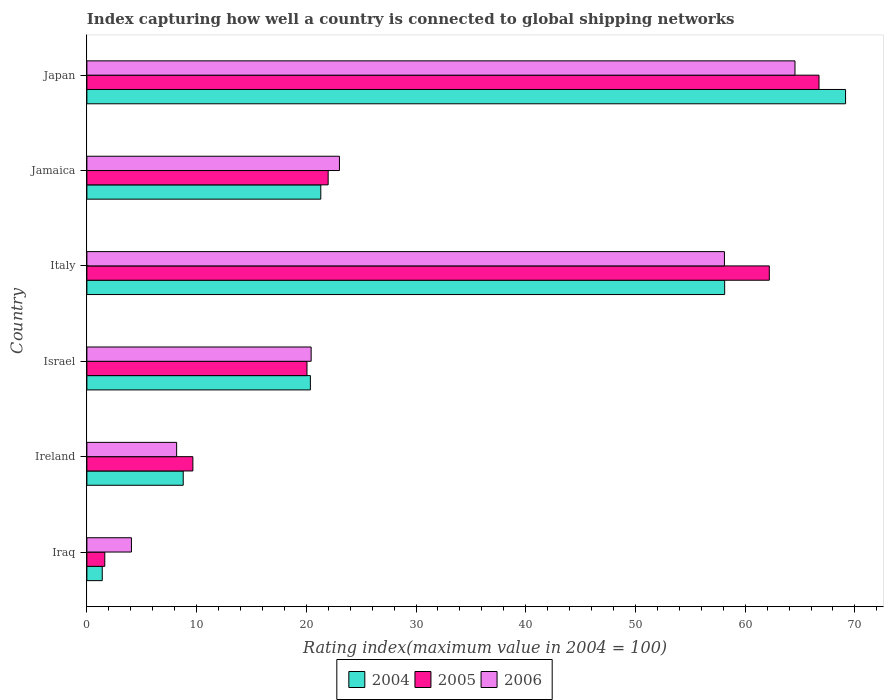Are the number of bars per tick equal to the number of legend labels?
Offer a very short reply. Yes. How many bars are there on the 3rd tick from the top?
Keep it short and to the point. 3. How many bars are there on the 3rd tick from the bottom?
Your answer should be compact. 3. In how many cases, is the number of bars for a given country not equal to the number of legend labels?
Offer a very short reply. 0. What is the rating index in 2005 in Iraq?
Ensure brevity in your answer.  1.63. Across all countries, what is the maximum rating index in 2006?
Provide a short and direct response. 64.54. Across all countries, what is the minimum rating index in 2006?
Ensure brevity in your answer.  4.06. In which country was the rating index in 2006 maximum?
Your answer should be very brief. Japan. In which country was the rating index in 2004 minimum?
Offer a terse response. Iraq. What is the total rating index in 2005 in the graph?
Provide a succinct answer. 182.27. What is the difference between the rating index in 2005 in Ireland and that in Japan?
Provide a succinct answer. -57.07. What is the difference between the rating index in 2006 in Israel and the rating index in 2004 in Japan?
Your answer should be compact. -48.71. What is the average rating index in 2006 per country?
Offer a very short reply. 29.72. What is the difference between the rating index in 2004 and rating index in 2006 in Israel?
Ensure brevity in your answer.  -0.07. What is the ratio of the rating index in 2006 in Iraq to that in Israel?
Ensure brevity in your answer.  0.2. What is the difference between the highest and the second highest rating index in 2006?
Your answer should be compact. 6.43. What is the difference between the highest and the lowest rating index in 2004?
Your answer should be compact. 67.75. Is the sum of the rating index in 2005 in Jamaica and Japan greater than the maximum rating index in 2004 across all countries?
Your answer should be compact. Yes. What does the 2nd bar from the top in Italy represents?
Give a very brief answer. 2005. Are all the bars in the graph horizontal?
Your answer should be compact. Yes. What is the difference between two consecutive major ticks on the X-axis?
Your answer should be compact. 10. Are the values on the major ticks of X-axis written in scientific E-notation?
Your answer should be very brief. No. Does the graph contain any zero values?
Give a very brief answer. No. How many legend labels are there?
Make the answer very short. 3. How are the legend labels stacked?
Make the answer very short. Horizontal. What is the title of the graph?
Your answer should be very brief. Index capturing how well a country is connected to global shipping networks. What is the label or title of the X-axis?
Provide a succinct answer. Rating index(maximum value in 2004 = 100). What is the label or title of the Y-axis?
Provide a short and direct response. Country. What is the Rating index(maximum value in 2004 = 100) of 2004 in Iraq?
Keep it short and to the point. 1.4. What is the Rating index(maximum value in 2004 = 100) of 2005 in Iraq?
Offer a very short reply. 1.63. What is the Rating index(maximum value in 2004 = 100) in 2006 in Iraq?
Keep it short and to the point. 4.06. What is the Rating index(maximum value in 2004 = 100) in 2004 in Ireland?
Offer a terse response. 8.78. What is the Rating index(maximum value in 2004 = 100) in 2005 in Ireland?
Make the answer very short. 9.66. What is the Rating index(maximum value in 2004 = 100) of 2006 in Ireland?
Your answer should be very brief. 8.18. What is the Rating index(maximum value in 2004 = 100) in 2004 in Israel?
Offer a terse response. 20.37. What is the Rating index(maximum value in 2004 = 100) of 2005 in Israel?
Provide a succinct answer. 20.06. What is the Rating index(maximum value in 2004 = 100) of 2006 in Israel?
Ensure brevity in your answer.  20.44. What is the Rating index(maximum value in 2004 = 100) in 2004 in Italy?
Ensure brevity in your answer.  58.13. What is the Rating index(maximum value in 2004 = 100) of 2005 in Italy?
Give a very brief answer. 62.2. What is the Rating index(maximum value in 2004 = 100) of 2006 in Italy?
Keep it short and to the point. 58.11. What is the Rating index(maximum value in 2004 = 100) of 2004 in Jamaica?
Give a very brief answer. 21.32. What is the Rating index(maximum value in 2004 = 100) of 2005 in Jamaica?
Keep it short and to the point. 21.99. What is the Rating index(maximum value in 2004 = 100) in 2006 in Jamaica?
Give a very brief answer. 23.02. What is the Rating index(maximum value in 2004 = 100) in 2004 in Japan?
Make the answer very short. 69.15. What is the Rating index(maximum value in 2004 = 100) in 2005 in Japan?
Keep it short and to the point. 66.73. What is the Rating index(maximum value in 2004 = 100) in 2006 in Japan?
Offer a very short reply. 64.54. Across all countries, what is the maximum Rating index(maximum value in 2004 = 100) in 2004?
Provide a succinct answer. 69.15. Across all countries, what is the maximum Rating index(maximum value in 2004 = 100) of 2005?
Give a very brief answer. 66.73. Across all countries, what is the maximum Rating index(maximum value in 2004 = 100) in 2006?
Provide a succinct answer. 64.54. Across all countries, what is the minimum Rating index(maximum value in 2004 = 100) of 2004?
Make the answer very short. 1.4. Across all countries, what is the minimum Rating index(maximum value in 2004 = 100) of 2005?
Provide a succinct answer. 1.63. Across all countries, what is the minimum Rating index(maximum value in 2004 = 100) of 2006?
Your response must be concise. 4.06. What is the total Rating index(maximum value in 2004 = 100) in 2004 in the graph?
Your response must be concise. 179.15. What is the total Rating index(maximum value in 2004 = 100) of 2005 in the graph?
Provide a succinct answer. 182.27. What is the total Rating index(maximum value in 2004 = 100) in 2006 in the graph?
Provide a short and direct response. 178.35. What is the difference between the Rating index(maximum value in 2004 = 100) of 2004 in Iraq and that in Ireland?
Ensure brevity in your answer.  -7.38. What is the difference between the Rating index(maximum value in 2004 = 100) in 2005 in Iraq and that in Ireland?
Your response must be concise. -8.03. What is the difference between the Rating index(maximum value in 2004 = 100) in 2006 in Iraq and that in Ireland?
Offer a terse response. -4.12. What is the difference between the Rating index(maximum value in 2004 = 100) in 2004 in Iraq and that in Israel?
Make the answer very short. -18.97. What is the difference between the Rating index(maximum value in 2004 = 100) in 2005 in Iraq and that in Israel?
Keep it short and to the point. -18.43. What is the difference between the Rating index(maximum value in 2004 = 100) of 2006 in Iraq and that in Israel?
Make the answer very short. -16.38. What is the difference between the Rating index(maximum value in 2004 = 100) of 2004 in Iraq and that in Italy?
Provide a short and direct response. -56.73. What is the difference between the Rating index(maximum value in 2004 = 100) of 2005 in Iraq and that in Italy?
Your answer should be very brief. -60.57. What is the difference between the Rating index(maximum value in 2004 = 100) of 2006 in Iraq and that in Italy?
Your response must be concise. -54.05. What is the difference between the Rating index(maximum value in 2004 = 100) in 2004 in Iraq and that in Jamaica?
Your answer should be compact. -19.92. What is the difference between the Rating index(maximum value in 2004 = 100) of 2005 in Iraq and that in Jamaica?
Your answer should be compact. -20.36. What is the difference between the Rating index(maximum value in 2004 = 100) of 2006 in Iraq and that in Jamaica?
Your response must be concise. -18.96. What is the difference between the Rating index(maximum value in 2004 = 100) of 2004 in Iraq and that in Japan?
Make the answer very short. -67.75. What is the difference between the Rating index(maximum value in 2004 = 100) in 2005 in Iraq and that in Japan?
Your answer should be very brief. -65.1. What is the difference between the Rating index(maximum value in 2004 = 100) of 2006 in Iraq and that in Japan?
Provide a short and direct response. -60.48. What is the difference between the Rating index(maximum value in 2004 = 100) of 2004 in Ireland and that in Israel?
Offer a terse response. -11.59. What is the difference between the Rating index(maximum value in 2004 = 100) of 2005 in Ireland and that in Israel?
Make the answer very short. -10.4. What is the difference between the Rating index(maximum value in 2004 = 100) of 2006 in Ireland and that in Israel?
Make the answer very short. -12.26. What is the difference between the Rating index(maximum value in 2004 = 100) of 2004 in Ireland and that in Italy?
Keep it short and to the point. -49.35. What is the difference between the Rating index(maximum value in 2004 = 100) in 2005 in Ireland and that in Italy?
Offer a terse response. -52.54. What is the difference between the Rating index(maximum value in 2004 = 100) in 2006 in Ireland and that in Italy?
Make the answer very short. -49.93. What is the difference between the Rating index(maximum value in 2004 = 100) of 2004 in Ireland and that in Jamaica?
Provide a short and direct response. -12.54. What is the difference between the Rating index(maximum value in 2004 = 100) in 2005 in Ireland and that in Jamaica?
Provide a succinct answer. -12.33. What is the difference between the Rating index(maximum value in 2004 = 100) in 2006 in Ireland and that in Jamaica?
Give a very brief answer. -14.84. What is the difference between the Rating index(maximum value in 2004 = 100) in 2004 in Ireland and that in Japan?
Make the answer very short. -60.37. What is the difference between the Rating index(maximum value in 2004 = 100) of 2005 in Ireland and that in Japan?
Your answer should be compact. -57.07. What is the difference between the Rating index(maximum value in 2004 = 100) of 2006 in Ireland and that in Japan?
Keep it short and to the point. -56.36. What is the difference between the Rating index(maximum value in 2004 = 100) of 2004 in Israel and that in Italy?
Give a very brief answer. -37.76. What is the difference between the Rating index(maximum value in 2004 = 100) of 2005 in Israel and that in Italy?
Your response must be concise. -42.14. What is the difference between the Rating index(maximum value in 2004 = 100) of 2006 in Israel and that in Italy?
Offer a terse response. -37.67. What is the difference between the Rating index(maximum value in 2004 = 100) in 2004 in Israel and that in Jamaica?
Offer a terse response. -0.95. What is the difference between the Rating index(maximum value in 2004 = 100) in 2005 in Israel and that in Jamaica?
Give a very brief answer. -1.93. What is the difference between the Rating index(maximum value in 2004 = 100) of 2006 in Israel and that in Jamaica?
Your response must be concise. -2.58. What is the difference between the Rating index(maximum value in 2004 = 100) of 2004 in Israel and that in Japan?
Your answer should be compact. -48.78. What is the difference between the Rating index(maximum value in 2004 = 100) of 2005 in Israel and that in Japan?
Provide a succinct answer. -46.67. What is the difference between the Rating index(maximum value in 2004 = 100) in 2006 in Israel and that in Japan?
Offer a very short reply. -44.1. What is the difference between the Rating index(maximum value in 2004 = 100) of 2004 in Italy and that in Jamaica?
Ensure brevity in your answer.  36.81. What is the difference between the Rating index(maximum value in 2004 = 100) of 2005 in Italy and that in Jamaica?
Your answer should be compact. 40.21. What is the difference between the Rating index(maximum value in 2004 = 100) in 2006 in Italy and that in Jamaica?
Give a very brief answer. 35.09. What is the difference between the Rating index(maximum value in 2004 = 100) of 2004 in Italy and that in Japan?
Give a very brief answer. -11.02. What is the difference between the Rating index(maximum value in 2004 = 100) of 2005 in Italy and that in Japan?
Provide a short and direct response. -4.53. What is the difference between the Rating index(maximum value in 2004 = 100) in 2006 in Italy and that in Japan?
Provide a short and direct response. -6.43. What is the difference between the Rating index(maximum value in 2004 = 100) of 2004 in Jamaica and that in Japan?
Your answer should be very brief. -47.83. What is the difference between the Rating index(maximum value in 2004 = 100) in 2005 in Jamaica and that in Japan?
Provide a short and direct response. -44.74. What is the difference between the Rating index(maximum value in 2004 = 100) in 2006 in Jamaica and that in Japan?
Your answer should be very brief. -41.52. What is the difference between the Rating index(maximum value in 2004 = 100) in 2004 in Iraq and the Rating index(maximum value in 2004 = 100) in 2005 in Ireland?
Give a very brief answer. -8.26. What is the difference between the Rating index(maximum value in 2004 = 100) of 2004 in Iraq and the Rating index(maximum value in 2004 = 100) of 2006 in Ireland?
Ensure brevity in your answer.  -6.78. What is the difference between the Rating index(maximum value in 2004 = 100) of 2005 in Iraq and the Rating index(maximum value in 2004 = 100) of 2006 in Ireland?
Offer a terse response. -6.55. What is the difference between the Rating index(maximum value in 2004 = 100) in 2004 in Iraq and the Rating index(maximum value in 2004 = 100) in 2005 in Israel?
Your answer should be very brief. -18.66. What is the difference between the Rating index(maximum value in 2004 = 100) of 2004 in Iraq and the Rating index(maximum value in 2004 = 100) of 2006 in Israel?
Provide a short and direct response. -19.04. What is the difference between the Rating index(maximum value in 2004 = 100) in 2005 in Iraq and the Rating index(maximum value in 2004 = 100) in 2006 in Israel?
Make the answer very short. -18.81. What is the difference between the Rating index(maximum value in 2004 = 100) of 2004 in Iraq and the Rating index(maximum value in 2004 = 100) of 2005 in Italy?
Keep it short and to the point. -60.8. What is the difference between the Rating index(maximum value in 2004 = 100) in 2004 in Iraq and the Rating index(maximum value in 2004 = 100) in 2006 in Italy?
Offer a very short reply. -56.71. What is the difference between the Rating index(maximum value in 2004 = 100) of 2005 in Iraq and the Rating index(maximum value in 2004 = 100) of 2006 in Italy?
Your answer should be very brief. -56.48. What is the difference between the Rating index(maximum value in 2004 = 100) of 2004 in Iraq and the Rating index(maximum value in 2004 = 100) of 2005 in Jamaica?
Your answer should be compact. -20.59. What is the difference between the Rating index(maximum value in 2004 = 100) in 2004 in Iraq and the Rating index(maximum value in 2004 = 100) in 2006 in Jamaica?
Give a very brief answer. -21.62. What is the difference between the Rating index(maximum value in 2004 = 100) in 2005 in Iraq and the Rating index(maximum value in 2004 = 100) in 2006 in Jamaica?
Your response must be concise. -21.39. What is the difference between the Rating index(maximum value in 2004 = 100) in 2004 in Iraq and the Rating index(maximum value in 2004 = 100) in 2005 in Japan?
Offer a very short reply. -65.33. What is the difference between the Rating index(maximum value in 2004 = 100) of 2004 in Iraq and the Rating index(maximum value in 2004 = 100) of 2006 in Japan?
Provide a short and direct response. -63.14. What is the difference between the Rating index(maximum value in 2004 = 100) of 2005 in Iraq and the Rating index(maximum value in 2004 = 100) of 2006 in Japan?
Your answer should be compact. -62.91. What is the difference between the Rating index(maximum value in 2004 = 100) in 2004 in Ireland and the Rating index(maximum value in 2004 = 100) in 2005 in Israel?
Keep it short and to the point. -11.28. What is the difference between the Rating index(maximum value in 2004 = 100) of 2004 in Ireland and the Rating index(maximum value in 2004 = 100) of 2006 in Israel?
Your answer should be compact. -11.66. What is the difference between the Rating index(maximum value in 2004 = 100) of 2005 in Ireland and the Rating index(maximum value in 2004 = 100) of 2006 in Israel?
Make the answer very short. -10.78. What is the difference between the Rating index(maximum value in 2004 = 100) of 2004 in Ireland and the Rating index(maximum value in 2004 = 100) of 2005 in Italy?
Keep it short and to the point. -53.42. What is the difference between the Rating index(maximum value in 2004 = 100) of 2004 in Ireland and the Rating index(maximum value in 2004 = 100) of 2006 in Italy?
Ensure brevity in your answer.  -49.33. What is the difference between the Rating index(maximum value in 2004 = 100) of 2005 in Ireland and the Rating index(maximum value in 2004 = 100) of 2006 in Italy?
Provide a succinct answer. -48.45. What is the difference between the Rating index(maximum value in 2004 = 100) in 2004 in Ireland and the Rating index(maximum value in 2004 = 100) in 2005 in Jamaica?
Your response must be concise. -13.21. What is the difference between the Rating index(maximum value in 2004 = 100) of 2004 in Ireland and the Rating index(maximum value in 2004 = 100) of 2006 in Jamaica?
Make the answer very short. -14.24. What is the difference between the Rating index(maximum value in 2004 = 100) of 2005 in Ireland and the Rating index(maximum value in 2004 = 100) of 2006 in Jamaica?
Provide a succinct answer. -13.36. What is the difference between the Rating index(maximum value in 2004 = 100) of 2004 in Ireland and the Rating index(maximum value in 2004 = 100) of 2005 in Japan?
Keep it short and to the point. -57.95. What is the difference between the Rating index(maximum value in 2004 = 100) in 2004 in Ireland and the Rating index(maximum value in 2004 = 100) in 2006 in Japan?
Your answer should be very brief. -55.76. What is the difference between the Rating index(maximum value in 2004 = 100) of 2005 in Ireland and the Rating index(maximum value in 2004 = 100) of 2006 in Japan?
Your answer should be very brief. -54.88. What is the difference between the Rating index(maximum value in 2004 = 100) in 2004 in Israel and the Rating index(maximum value in 2004 = 100) in 2005 in Italy?
Provide a short and direct response. -41.83. What is the difference between the Rating index(maximum value in 2004 = 100) in 2004 in Israel and the Rating index(maximum value in 2004 = 100) in 2006 in Italy?
Offer a very short reply. -37.74. What is the difference between the Rating index(maximum value in 2004 = 100) in 2005 in Israel and the Rating index(maximum value in 2004 = 100) in 2006 in Italy?
Your answer should be very brief. -38.05. What is the difference between the Rating index(maximum value in 2004 = 100) in 2004 in Israel and the Rating index(maximum value in 2004 = 100) in 2005 in Jamaica?
Your answer should be very brief. -1.62. What is the difference between the Rating index(maximum value in 2004 = 100) in 2004 in Israel and the Rating index(maximum value in 2004 = 100) in 2006 in Jamaica?
Offer a terse response. -2.65. What is the difference between the Rating index(maximum value in 2004 = 100) of 2005 in Israel and the Rating index(maximum value in 2004 = 100) of 2006 in Jamaica?
Ensure brevity in your answer.  -2.96. What is the difference between the Rating index(maximum value in 2004 = 100) of 2004 in Israel and the Rating index(maximum value in 2004 = 100) of 2005 in Japan?
Ensure brevity in your answer.  -46.36. What is the difference between the Rating index(maximum value in 2004 = 100) in 2004 in Israel and the Rating index(maximum value in 2004 = 100) in 2006 in Japan?
Offer a very short reply. -44.17. What is the difference between the Rating index(maximum value in 2004 = 100) of 2005 in Israel and the Rating index(maximum value in 2004 = 100) of 2006 in Japan?
Ensure brevity in your answer.  -44.48. What is the difference between the Rating index(maximum value in 2004 = 100) in 2004 in Italy and the Rating index(maximum value in 2004 = 100) in 2005 in Jamaica?
Provide a short and direct response. 36.14. What is the difference between the Rating index(maximum value in 2004 = 100) in 2004 in Italy and the Rating index(maximum value in 2004 = 100) in 2006 in Jamaica?
Give a very brief answer. 35.11. What is the difference between the Rating index(maximum value in 2004 = 100) in 2005 in Italy and the Rating index(maximum value in 2004 = 100) in 2006 in Jamaica?
Provide a succinct answer. 39.18. What is the difference between the Rating index(maximum value in 2004 = 100) in 2004 in Italy and the Rating index(maximum value in 2004 = 100) in 2005 in Japan?
Make the answer very short. -8.6. What is the difference between the Rating index(maximum value in 2004 = 100) of 2004 in Italy and the Rating index(maximum value in 2004 = 100) of 2006 in Japan?
Provide a succinct answer. -6.41. What is the difference between the Rating index(maximum value in 2004 = 100) in 2005 in Italy and the Rating index(maximum value in 2004 = 100) in 2006 in Japan?
Keep it short and to the point. -2.34. What is the difference between the Rating index(maximum value in 2004 = 100) in 2004 in Jamaica and the Rating index(maximum value in 2004 = 100) in 2005 in Japan?
Provide a short and direct response. -45.41. What is the difference between the Rating index(maximum value in 2004 = 100) of 2004 in Jamaica and the Rating index(maximum value in 2004 = 100) of 2006 in Japan?
Offer a very short reply. -43.22. What is the difference between the Rating index(maximum value in 2004 = 100) in 2005 in Jamaica and the Rating index(maximum value in 2004 = 100) in 2006 in Japan?
Offer a very short reply. -42.55. What is the average Rating index(maximum value in 2004 = 100) in 2004 per country?
Offer a terse response. 29.86. What is the average Rating index(maximum value in 2004 = 100) in 2005 per country?
Keep it short and to the point. 30.38. What is the average Rating index(maximum value in 2004 = 100) of 2006 per country?
Your answer should be compact. 29.73. What is the difference between the Rating index(maximum value in 2004 = 100) of 2004 and Rating index(maximum value in 2004 = 100) of 2005 in Iraq?
Your answer should be very brief. -0.23. What is the difference between the Rating index(maximum value in 2004 = 100) in 2004 and Rating index(maximum value in 2004 = 100) in 2006 in Iraq?
Ensure brevity in your answer.  -2.66. What is the difference between the Rating index(maximum value in 2004 = 100) of 2005 and Rating index(maximum value in 2004 = 100) of 2006 in Iraq?
Keep it short and to the point. -2.43. What is the difference between the Rating index(maximum value in 2004 = 100) of 2004 and Rating index(maximum value in 2004 = 100) of 2005 in Ireland?
Provide a succinct answer. -0.88. What is the difference between the Rating index(maximum value in 2004 = 100) in 2005 and Rating index(maximum value in 2004 = 100) in 2006 in Ireland?
Give a very brief answer. 1.48. What is the difference between the Rating index(maximum value in 2004 = 100) of 2004 and Rating index(maximum value in 2004 = 100) of 2005 in Israel?
Keep it short and to the point. 0.31. What is the difference between the Rating index(maximum value in 2004 = 100) in 2004 and Rating index(maximum value in 2004 = 100) in 2006 in Israel?
Provide a short and direct response. -0.07. What is the difference between the Rating index(maximum value in 2004 = 100) in 2005 and Rating index(maximum value in 2004 = 100) in 2006 in Israel?
Your response must be concise. -0.38. What is the difference between the Rating index(maximum value in 2004 = 100) of 2004 and Rating index(maximum value in 2004 = 100) of 2005 in Italy?
Give a very brief answer. -4.07. What is the difference between the Rating index(maximum value in 2004 = 100) in 2005 and Rating index(maximum value in 2004 = 100) in 2006 in Italy?
Offer a very short reply. 4.09. What is the difference between the Rating index(maximum value in 2004 = 100) of 2004 and Rating index(maximum value in 2004 = 100) of 2005 in Jamaica?
Offer a terse response. -0.67. What is the difference between the Rating index(maximum value in 2004 = 100) of 2004 and Rating index(maximum value in 2004 = 100) of 2006 in Jamaica?
Provide a short and direct response. -1.7. What is the difference between the Rating index(maximum value in 2004 = 100) in 2005 and Rating index(maximum value in 2004 = 100) in 2006 in Jamaica?
Keep it short and to the point. -1.03. What is the difference between the Rating index(maximum value in 2004 = 100) of 2004 and Rating index(maximum value in 2004 = 100) of 2005 in Japan?
Provide a succinct answer. 2.42. What is the difference between the Rating index(maximum value in 2004 = 100) in 2004 and Rating index(maximum value in 2004 = 100) in 2006 in Japan?
Your response must be concise. 4.61. What is the difference between the Rating index(maximum value in 2004 = 100) in 2005 and Rating index(maximum value in 2004 = 100) in 2006 in Japan?
Your answer should be compact. 2.19. What is the ratio of the Rating index(maximum value in 2004 = 100) in 2004 in Iraq to that in Ireland?
Make the answer very short. 0.16. What is the ratio of the Rating index(maximum value in 2004 = 100) of 2005 in Iraq to that in Ireland?
Provide a succinct answer. 0.17. What is the ratio of the Rating index(maximum value in 2004 = 100) of 2006 in Iraq to that in Ireland?
Make the answer very short. 0.5. What is the ratio of the Rating index(maximum value in 2004 = 100) in 2004 in Iraq to that in Israel?
Keep it short and to the point. 0.07. What is the ratio of the Rating index(maximum value in 2004 = 100) of 2005 in Iraq to that in Israel?
Make the answer very short. 0.08. What is the ratio of the Rating index(maximum value in 2004 = 100) in 2006 in Iraq to that in Israel?
Your answer should be compact. 0.2. What is the ratio of the Rating index(maximum value in 2004 = 100) of 2004 in Iraq to that in Italy?
Offer a terse response. 0.02. What is the ratio of the Rating index(maximum value in 2004 = 100) in 2005 in Iraq to that in Italy?
Give a very brief answer. 0.03. What is the ratio of the Rating index(maximum value in 2004 = 100) of 2006 in Iraq to that in Italy?
Ensure brevity in your answer.  0.07. What is the ratio of the Rating index(maximum value in 2004 = 100) of 2004 in Iraq to that in Jamaica?
Ensure brevity in your answer.  0.07. What is the ratio of the Rating index(maximum value in 2004 = 100) of 2005 in Iraq to that in Jamaica?
Offer a very short reply. 0.07. What is the ratio of the Rating index(maximum value in 2004 = 100) in 2006 in Iraq to that in Jamaica?
Make the answer very short. 0.18. What is the ratio of the Rating index(maximum value in 2004 = 100) in 2004 in Iraq to that in Japan?
Your answer should be compact. 0.02. What is the ratio of the Rating index(maximum value in 2004 = 100) of 2005 in Iraq to that in Japan?
Provide a succinct answer. 0.02. What is the ratio of the Rating index(maximum value in 2004 = 100) in 2006 in Iraq to that in Japan?
Provide a succinct answer. 0.06. What is the ratio of the Rating index(maximum value in 2004 = 100) of 2004 in Ireland to that in Israel?
Offer a very short reply. 0.43. What is the ratio of the Rating index(maximum value in 2004 = 100) of 2005 in Ireland to that in Israel?
Offer a very short reply. 0.48. What is the ratio of the Rating index(maximum value in 2004 = 100) in 2006 in Ireland to that in Israel?
Provide a short and direct response. 0.4. What is the ratio of the Rating index(maximum value in 2004 = 100) in 2004 in Ireland to that in Italy?
Make the answer very short. 0.15. What is the ratio of the Rating index(maximum value in 2004 = 100) in 2005 in Ireland to that in Italy?
Ensure brevity in your answer.  0.16. What is the ratio of the Rating index(maximum value in 2004 = 100) of 2006 in Ireland to that in Italy?
Make the answer very short. 0.14. What is the ratio of the Rating index(maximum value in 2004 = 100) in 2004 in Ireland to that in Jamaica?
Give a very brief answer. 0.41. What is the ratio of the Rating index(maximum value in 2004 = 100) in 2005 in Ireland to that in Jamaica?
Make the answer very short. 0.44. What is the ratio of the Rating index(maximum value in 2004 = 100) of 2006 in Ireland to that in Jamaica?
Keep it short and to the point. 0.36. What is the ratio of the Rating index(maximum value in 2004 = 100) in 2004 in Ireland to that in Japan?
Your response must be concise. 0.13. What is the ratio of the Rating index(maximum value in 2004 = 100) in 2005 in Ireland to that in Japan?
Provide a succinct answer. 0.14. What is the ratio of the Rating index(maximum value in 2004 = 100) of 2006 in Ireland to that in Japan?
Offer a very short reply. 0.13. What is the ratio of the Rating index(maximum value in 2004 = 100) of 2004 in Israel to that in Italy?
Keep it short and to the point. 0.35. What is the ratio of the Rating index(maximum value in 2004 = 100) in 2005 in Israel to that in Italy?
Keep it short and to the point. 0.32. What is the ratio of the Rating index(maximum value in 2004 = 100) in 2006 in Israel to that in Italy?
Offer a very short reply. 0.35. What is the ratio of the Rating index(maximum value in 2004 = 100) of 2004 in Israel to that in Jamaica?
Offer a terse response. 0.96. What is the ratio of the Rating index(maximum value in 2004 = 100) of 2005 in Israel to that in Jamaica?
Your answer should be compact. 0.91. What is the ratio of the Rating index(maximum value in 2004 = 100) of 2006 in Israel to that in Jamaica?
Offer a very short reply. 0.89. What is the ratio of the Rating index(maximum value in 2004 = 100) in 2004 in Israel to that in Japan?
Make the answer very short. 0.29. What is the ratio of the Rating index(maximum value in 2004 = 100) in 2005 in Israel to that in Japan?
Offer a terse response. 0.3. What is the ratio of the Rating index(maximum value in 2004 = 100) in 2006 in Israel to that in Japan?
Offer a very short reply. 0.32. What is the ratio of the Rating index(maximum value in 2004 = 100) of 2004 in Italy to that in Jamaica?
Offer a terse response. 2.73. What is the ratio of the Rating index(maximum value in 2004 = 100) of 2005 in Italy to that in Jamaica?
Make the answer very short. 2.83. What is the ratio of the Rating index(maximum value in 2004 = 100) in 2006 in Italy to that in Jamaica?
Your response must be concise. 2.52. What is the ratio of the Rating index(maximum value in 2004 = 100) in 2004 in Italy to that in Japan?
Your answer should be very brief. 0.84. What is the ratio of the Rating index(maximum value in 2004 = 100) in 2005 in Italy to that in Japan?
Offer a very short reply. 0.93. What is the ratio of the Rating index(maximum value in 2004 = 100) of 2006 in Italy to that in Japan?
Give a very brief answer. 0.9. What is the ratio of the Rating index(maximum value in 2004 = 100) in 2004 in Jamaica to that in Japan?
Ensure brevity in your answer.  0.31. What is the ratio of the Rating index(maximum value in 2004 = 100) in 2005 in Jamaica to that in Japan?
Ensure brevity in your answer.  0.33. What is the ratio of the Rating index(maximum value in 2004 = 100) of 2006 in Jamaica to that in Japan?
Provide a succinct answer. 0.36. What is the difference between the highest and the second highest Rating index(maximum value in 2004 = 100) in 2004?
Your answer should be compact. 11.02. What is the difference between the highest and the second highest Rating index(maximum value in 2004 = 100) in 2005?
Provide a succinct answer. 4.53. What is the difference between the highest and the second highest Rating index(maximum value in 2004 = 100) of 2006?
Your answer should be very brief. 6.43. What is the difference between the highest and the lowest Rating index(maximum value in 2004 = 100) of 2004?
Offer a very short reply. 67.75. What is the difference between the highest and the lowest Rating index(maximum value in 2004 = 100) in 2005?
Give a very brief answer. 65.1. What is the difference between the highest and the lowest Rating index(maximum value in 2004 = 100) of 2006?
Your answer should be very brief. 60.48. 